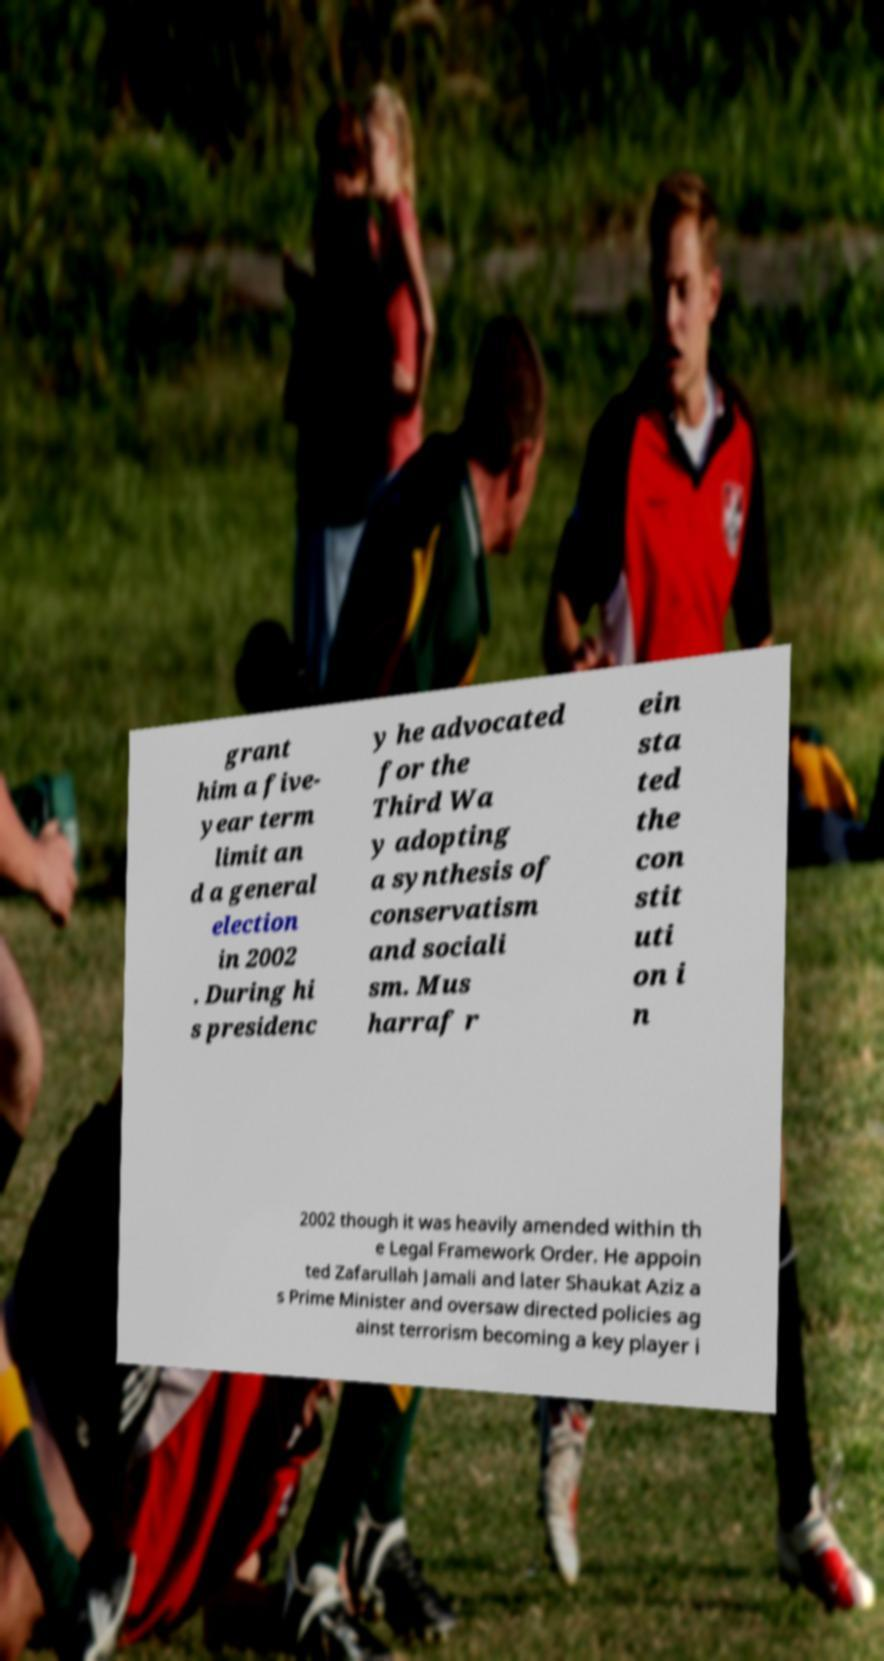I need the written content from this picture converted into text. Can you do that? grant him a five- year term limit an d a general election in 2002 . During hi s presidenc y he advocated for the Third Wa y adopting a synthesis of conservatism and sociali sm. Mus harraf r ein sta ted the con stit uti on i n 2002 though it was heavily amended within th e Legal Framework Order. He appoin ted Zafarullah Jamali and later Shaukat Aziz a s Prime Minister and oversaw directed policies ag ainst terrorism becoming a key player i 